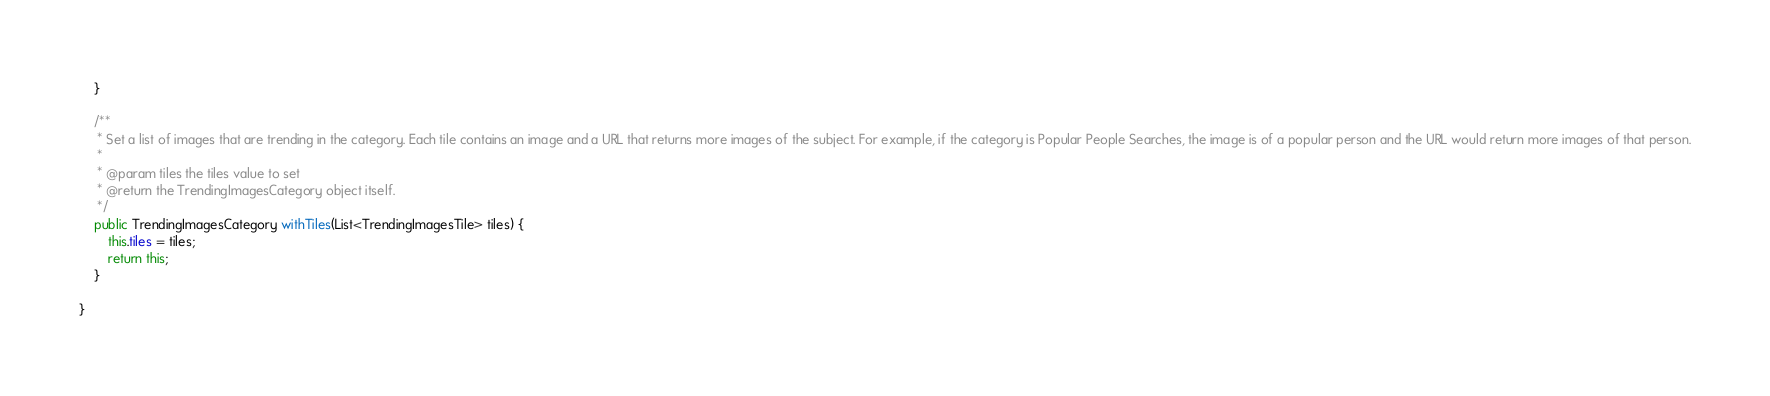Convert code to text. <code><loc_0><loc_0><loc_500><loc_500><_Java_>    }

    /**
     * Set a list of images that are trending in the category. Each tile contains an image and a URL that returns more images of the subject. For example, if the category is Popular People Searches, the image is of a popular person and the URL would return more images of that person.
     *
     * @param tiles the tiles value to set
     * @return the TrendingImagesCategory object itself.
     */
    public TrendingImagesCategory withTiles(List<TrendingImagesTile> tiles) {
        this.tiles = tiles;
        return this;
    }

}
</code> 